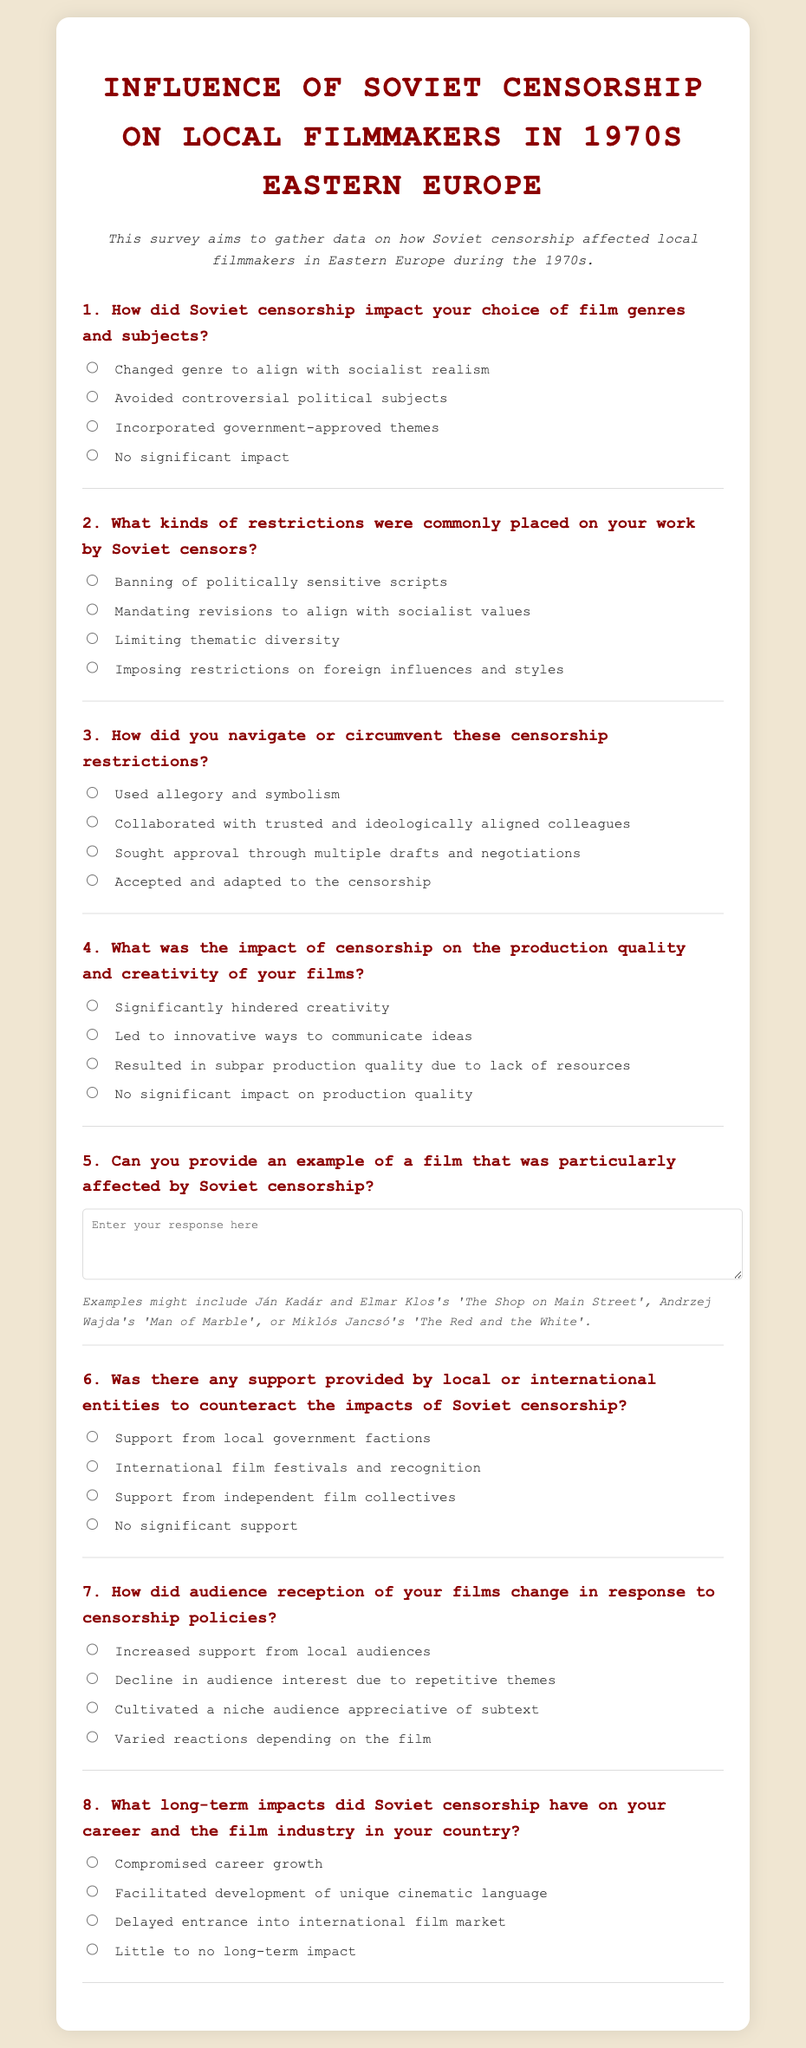What is the title of the survey? The title of the survey is prominently displayed at the top of the document and is "Influence of Soviet Censorship on Local Filmmakers in 1970s Eastern Europe."
Answer: Influence of Soviet Censorship on Local Filmmakers in 1970s Eastern Europe What is the main aim of the survey? The document states that the survey aims to gather data on how Soviet censorship affected local filmmakers in Eastern Europe during the 1970s.
Answer: Gather data on how Soviet censorship affected local filmmakers How many questions are included in the survey? The survey contains a total of eight questions addressing various aspects of the impact of Soviet censorship.
Answer: Eight What is the second type of restriction commonly placed on filmmakers? In the survey, the second restriction mentioned is "Mandating revisions to align with socialist values."
Answer: Mandating revisions to align with socialist values How did filmmakers navigate censorship restrictions according to the survey? The survey offers several answers; one of them is "Used allegory and symbolism."
Answer: Used allegory and symbolism What is an example of a film affected by Soviet censorship mentioned in the hint? The hint provided in the survey gives "The Shop on Main Street" as an example of a film that was particularly affected by censorship.
Answer: The Shop on Main Street Which group was specified as potentially providing support against censorship? The survey outlines "Support from independent film collectives" as one of the possible sources of support against censorship impacts.
Answer: Support from independent film collectives What long-term impact on career growth is mentioned in the survey? The survey indicates "Compromised career growth" as a potential long-term impact of censorship on filmmakers' careers.
Answer: Compromised career growth 